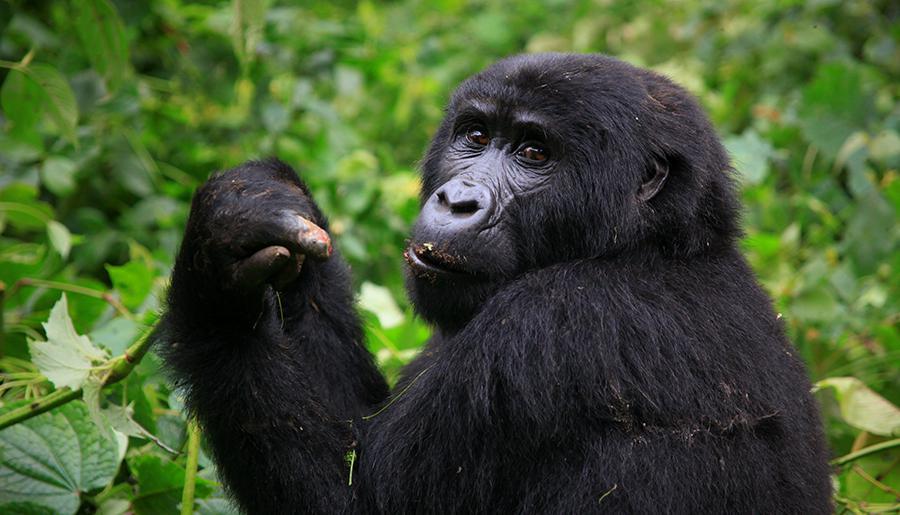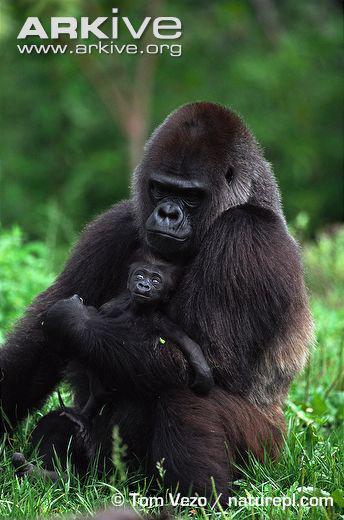The first image is the image on the left, the second image is the image on the right. Considering the images on both sides, is "A person holding a camera is near an adult gorilla in the left image." valid? Answer yes or no. No. The first image is the image on the left, the second image is the image on the right. Considering the images on both sides, is "The left image contains a human interacting with a gorilla." valid? Answer yes or no. No. 